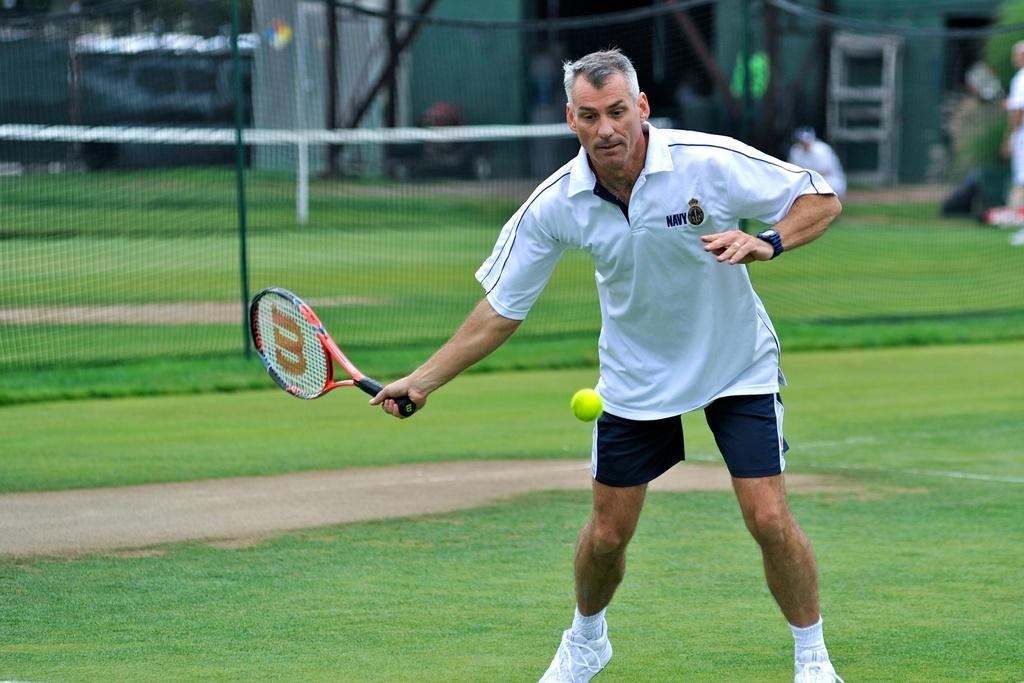What type of vegetation can be seen in the image? There is grass in the image. What structure is present in the image? There is a fence in the image. What is the man in the image holding? The man is holding a shuttle bat in the image. What is the color of the boll in the image? The boll in the image is yellow. Can you tell me how many moons are visible in the image? There are no moons visible in the image; it features grass, a fence, a man holding a shuttle bat, and a yellow-colored boll. Is the man in the image a beginner at playing with the shuttle bat? The image does not provide any information about the man's skill level or experience with the shuttle bat. 